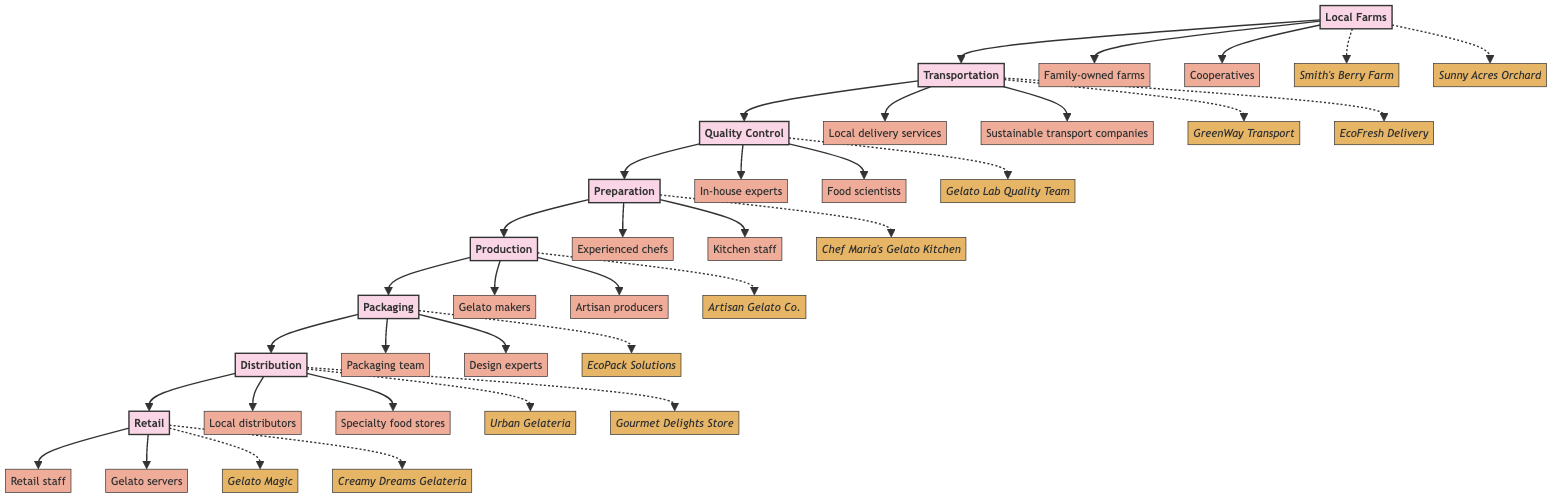What is the first stage in the sourcing process? The first stage in the sourcing process is "Local Farms," which is indicated as the bottom node in the flowchart.
Answer: Local Farms How many main stages are there in the gelato sourcing process? By counting the stages represented in the diagram, I find there are a total of 8 main stages listed from Local Farms to Retail.
Answer: 8 What stage comes directly after Quality Control? Following the flow of the diagram, the stage that comes directly after "Quality Control" is "Preparation."
Answer: Preparation Which stage involves "Experienced chefs"? The stage where "Experienced chefs" are mentioned is "Preparation," as indicated in the diagram.
Answer: Preparation Who are the actors in the Distribution stage? The actors specified for the "Distribution" stage are "Local distributors" and "Specialty food stores," both mentioned in the diagram.
Answer: Local distributors, Specialty food stores What is the final stage in the gelato sourcing process? The final stage in the sourcing process is "Retail," which is the topmost stage in the flowchart.
Answer: Retail Which stage is responsible for packaging? The stage responsible for packaging is "Packaging," as clearly labeled in the flowchart.
Answer: Packaging What type of companies are involved in the Transportation stage? The Transportation stage involves "Local delivery services" and "Sustainable transport companies," according to the information in the diagram.
Answer: Local delivery services, Sustainable transport companies How many actors are involved in the Production stage? In the Production stage, there are two actors mentioned: "Gelato makers" and "Artisan producers," which totals to two actors.
Answer: 2 